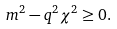<formula> <loc_0><loc_0><loc_500><loc_500>m ^ { 2 } - q ^ { 2 } \chi ^ { 2 } \geq 0 .</formula> 